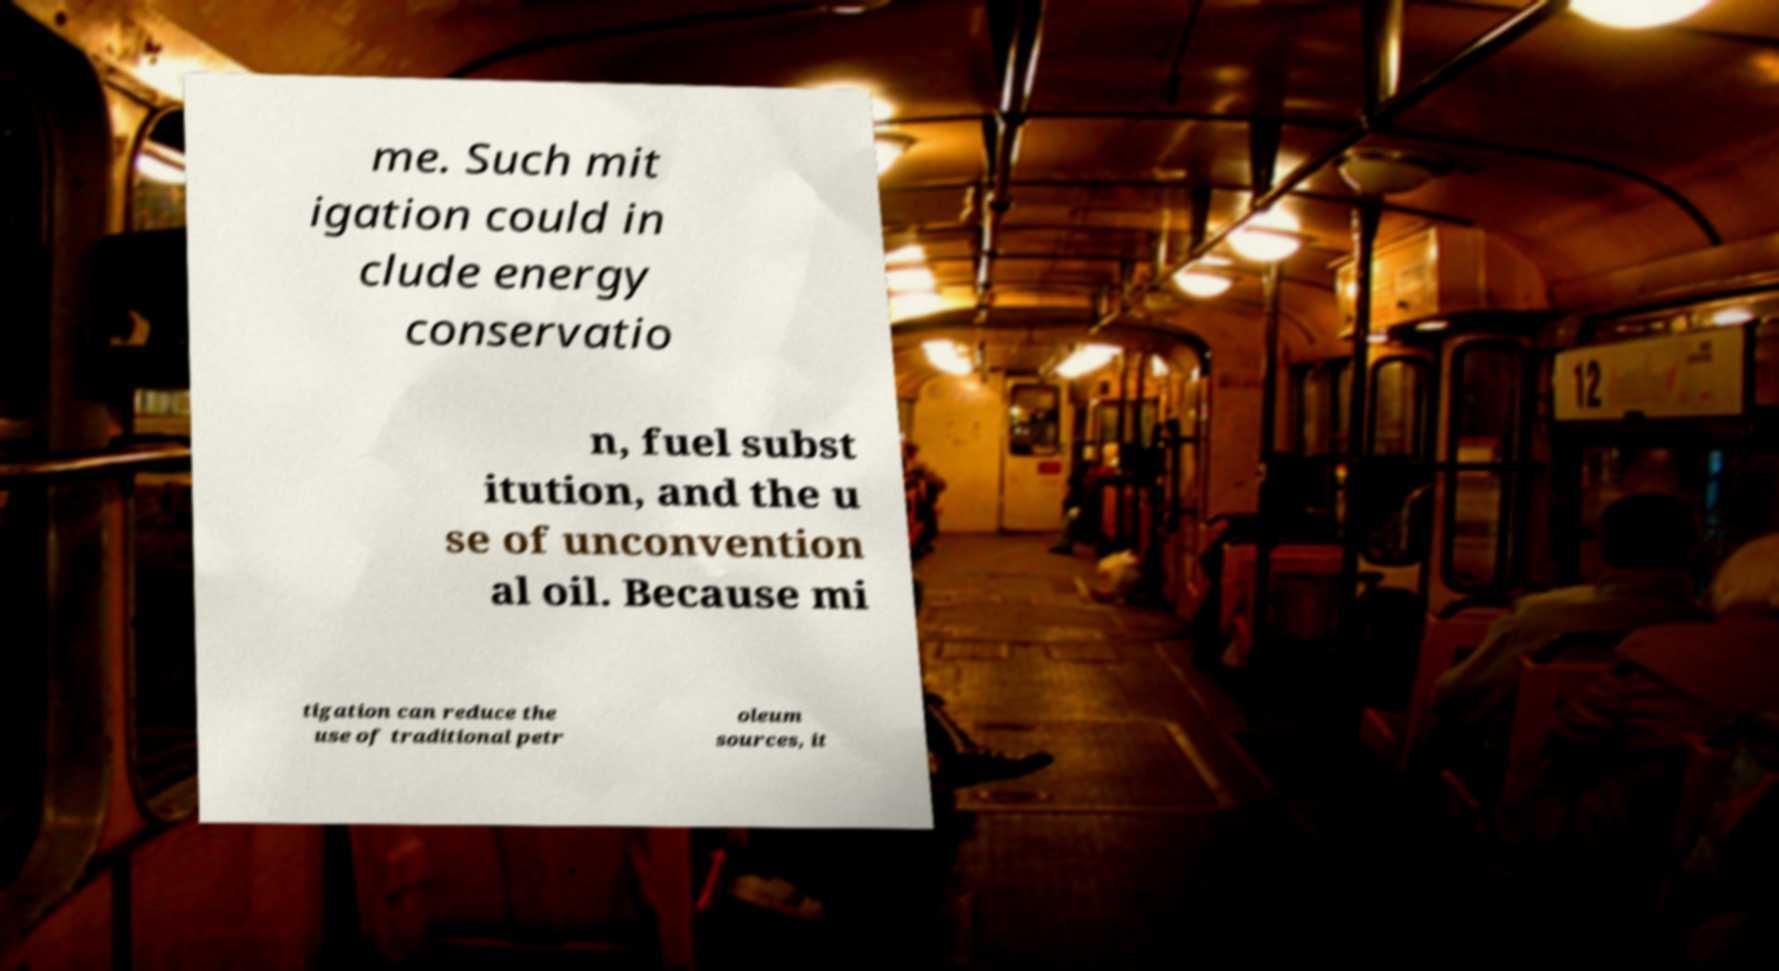What messages or text are displayed in this image? I need them in a readable, typed format. me. Such mit igation could in clude energy conservatio n, fuel subst itution, and the u se of unconvention al oil. Because mi tigation can reduce the use of traditional petr oleum sources, it 